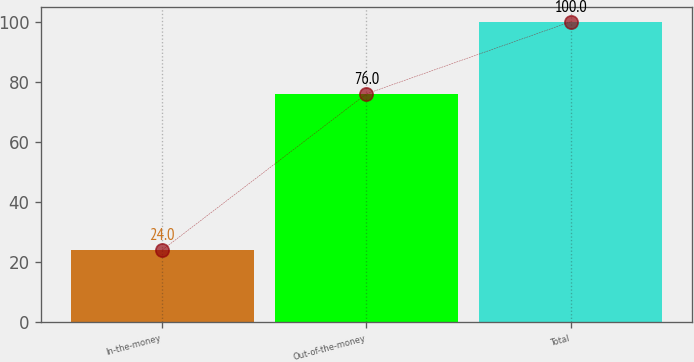Convert chart. <chart><loc_0><loc_0><loc_500><loc_500><bar_chart><fcel>In-the-money<fcel>Out-of-the-money<fcel>Total<nl><fcel>24<fcel>76<fcel>100<nl></chart> 